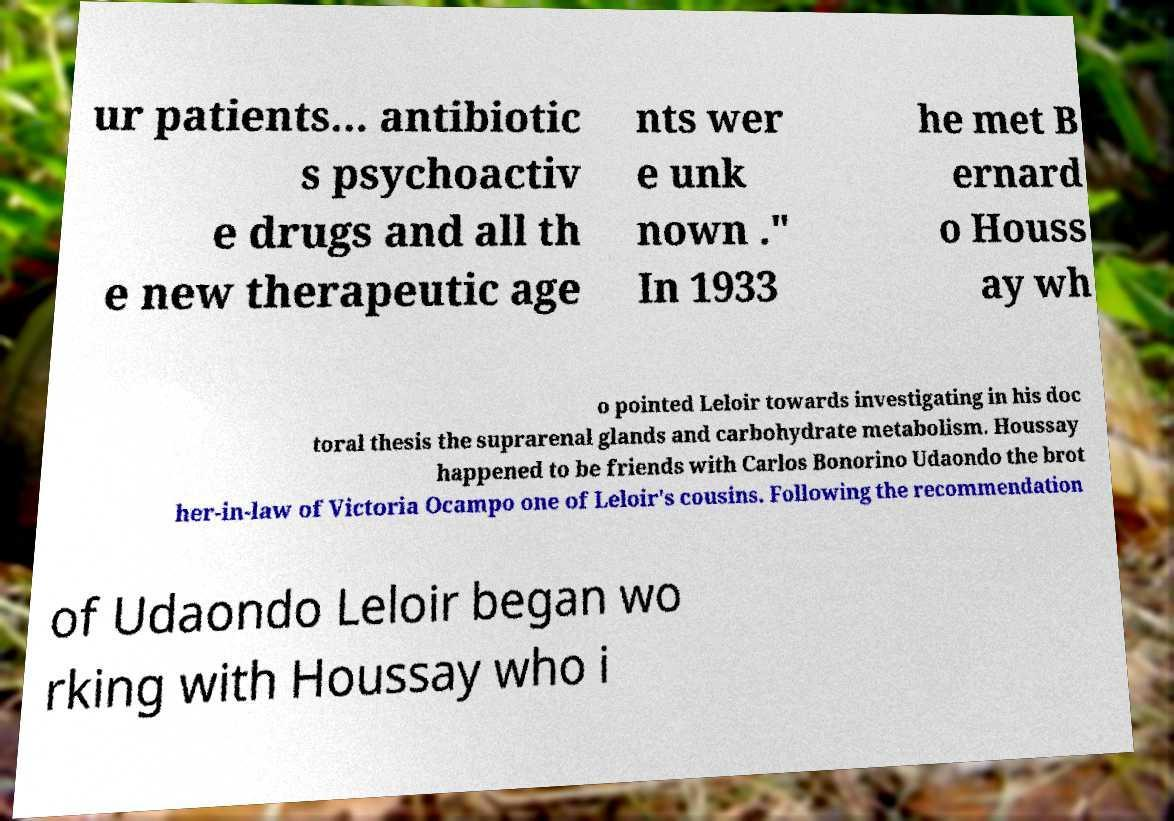For documentation purposes, I need the text within this image transcribed. Could you provide that? ur patients... antibiotic s psychoactiv e drugs and all th e new therapeutic age nts wer e unk nown ." In 1933 he met B ernard o Houss ay wh o pointed Leloir towards investigating in his doc toral thesis the suprarenal glands and carbohydrate metabolism. Houssay happened to be friends with Carlos Bonorino Udaondo the brot her-in-law of Victoria Ocampo one of Leloir's cousins. Following the recommendation of Udaondo Leloir began wo rking with Houssay who i 